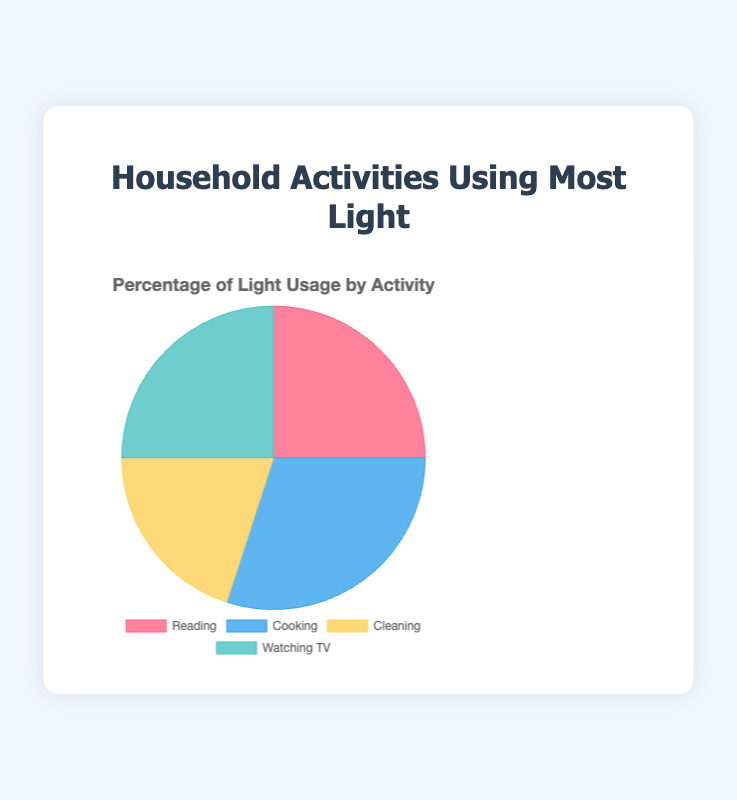Which activity accounts for the largest percentage of light usage? The activity with the highest percentage is Cooking at 30%, as indicated by the slice size in the pie chart.
Answer: Cooking What is the total percentage of light usage for activities that use equal amounts of light? Reading and Watching TV each account for 25% of light usage. Summing these two gives 25% + 25% = 50%.
Answer: 50% How much more light usage does Cooking require compared to Cleaning? Cooking accounts for 30% of light usage and Cleaning accounts for 20%, so Cooking requires 30% - 20% = 10% more light usage.
Answer: 10% Which activities combined make up exactly half of the total light usage? Reading (25%) and Watching TV (25%) together make up 25% + 25% = 50%.
Answer: Reading and Watching TV Are there any activities that use the same percentage of light? Yes, Reading and Watching TV both use 25% of the household light.
Answer: Yes What is the average percentage of light usage across all activities? Summing the percentages: 25% (Reading) + 30% (Cooking) + 20% (Cleaning) + 25% (Watching TV) = 100%. Dividing by four activities: 100% / 4 = 25%.
Answer: 25% What percentage of light is used by activities other than Cooking? Adding percentages for Reading (25%), Cleaning (20%), and Watching TV (25%), we get 25% + 20% + 25% = 70%.
Answer: 70% By how much does the highest light-using activity exceed the lowest light-using activity? Cooking uses 30%, the highest, and Cleaning uses 20%, the lowest. The difference is 30% - 20% = 10%.
Answer: 10% What is the ratio of light usage for Reading to Cooking? Light usage for Reading is 25% and for Cooking is 30%. The ratio is 25:30, which simplifies to 5:6.
Answer: 5:6 